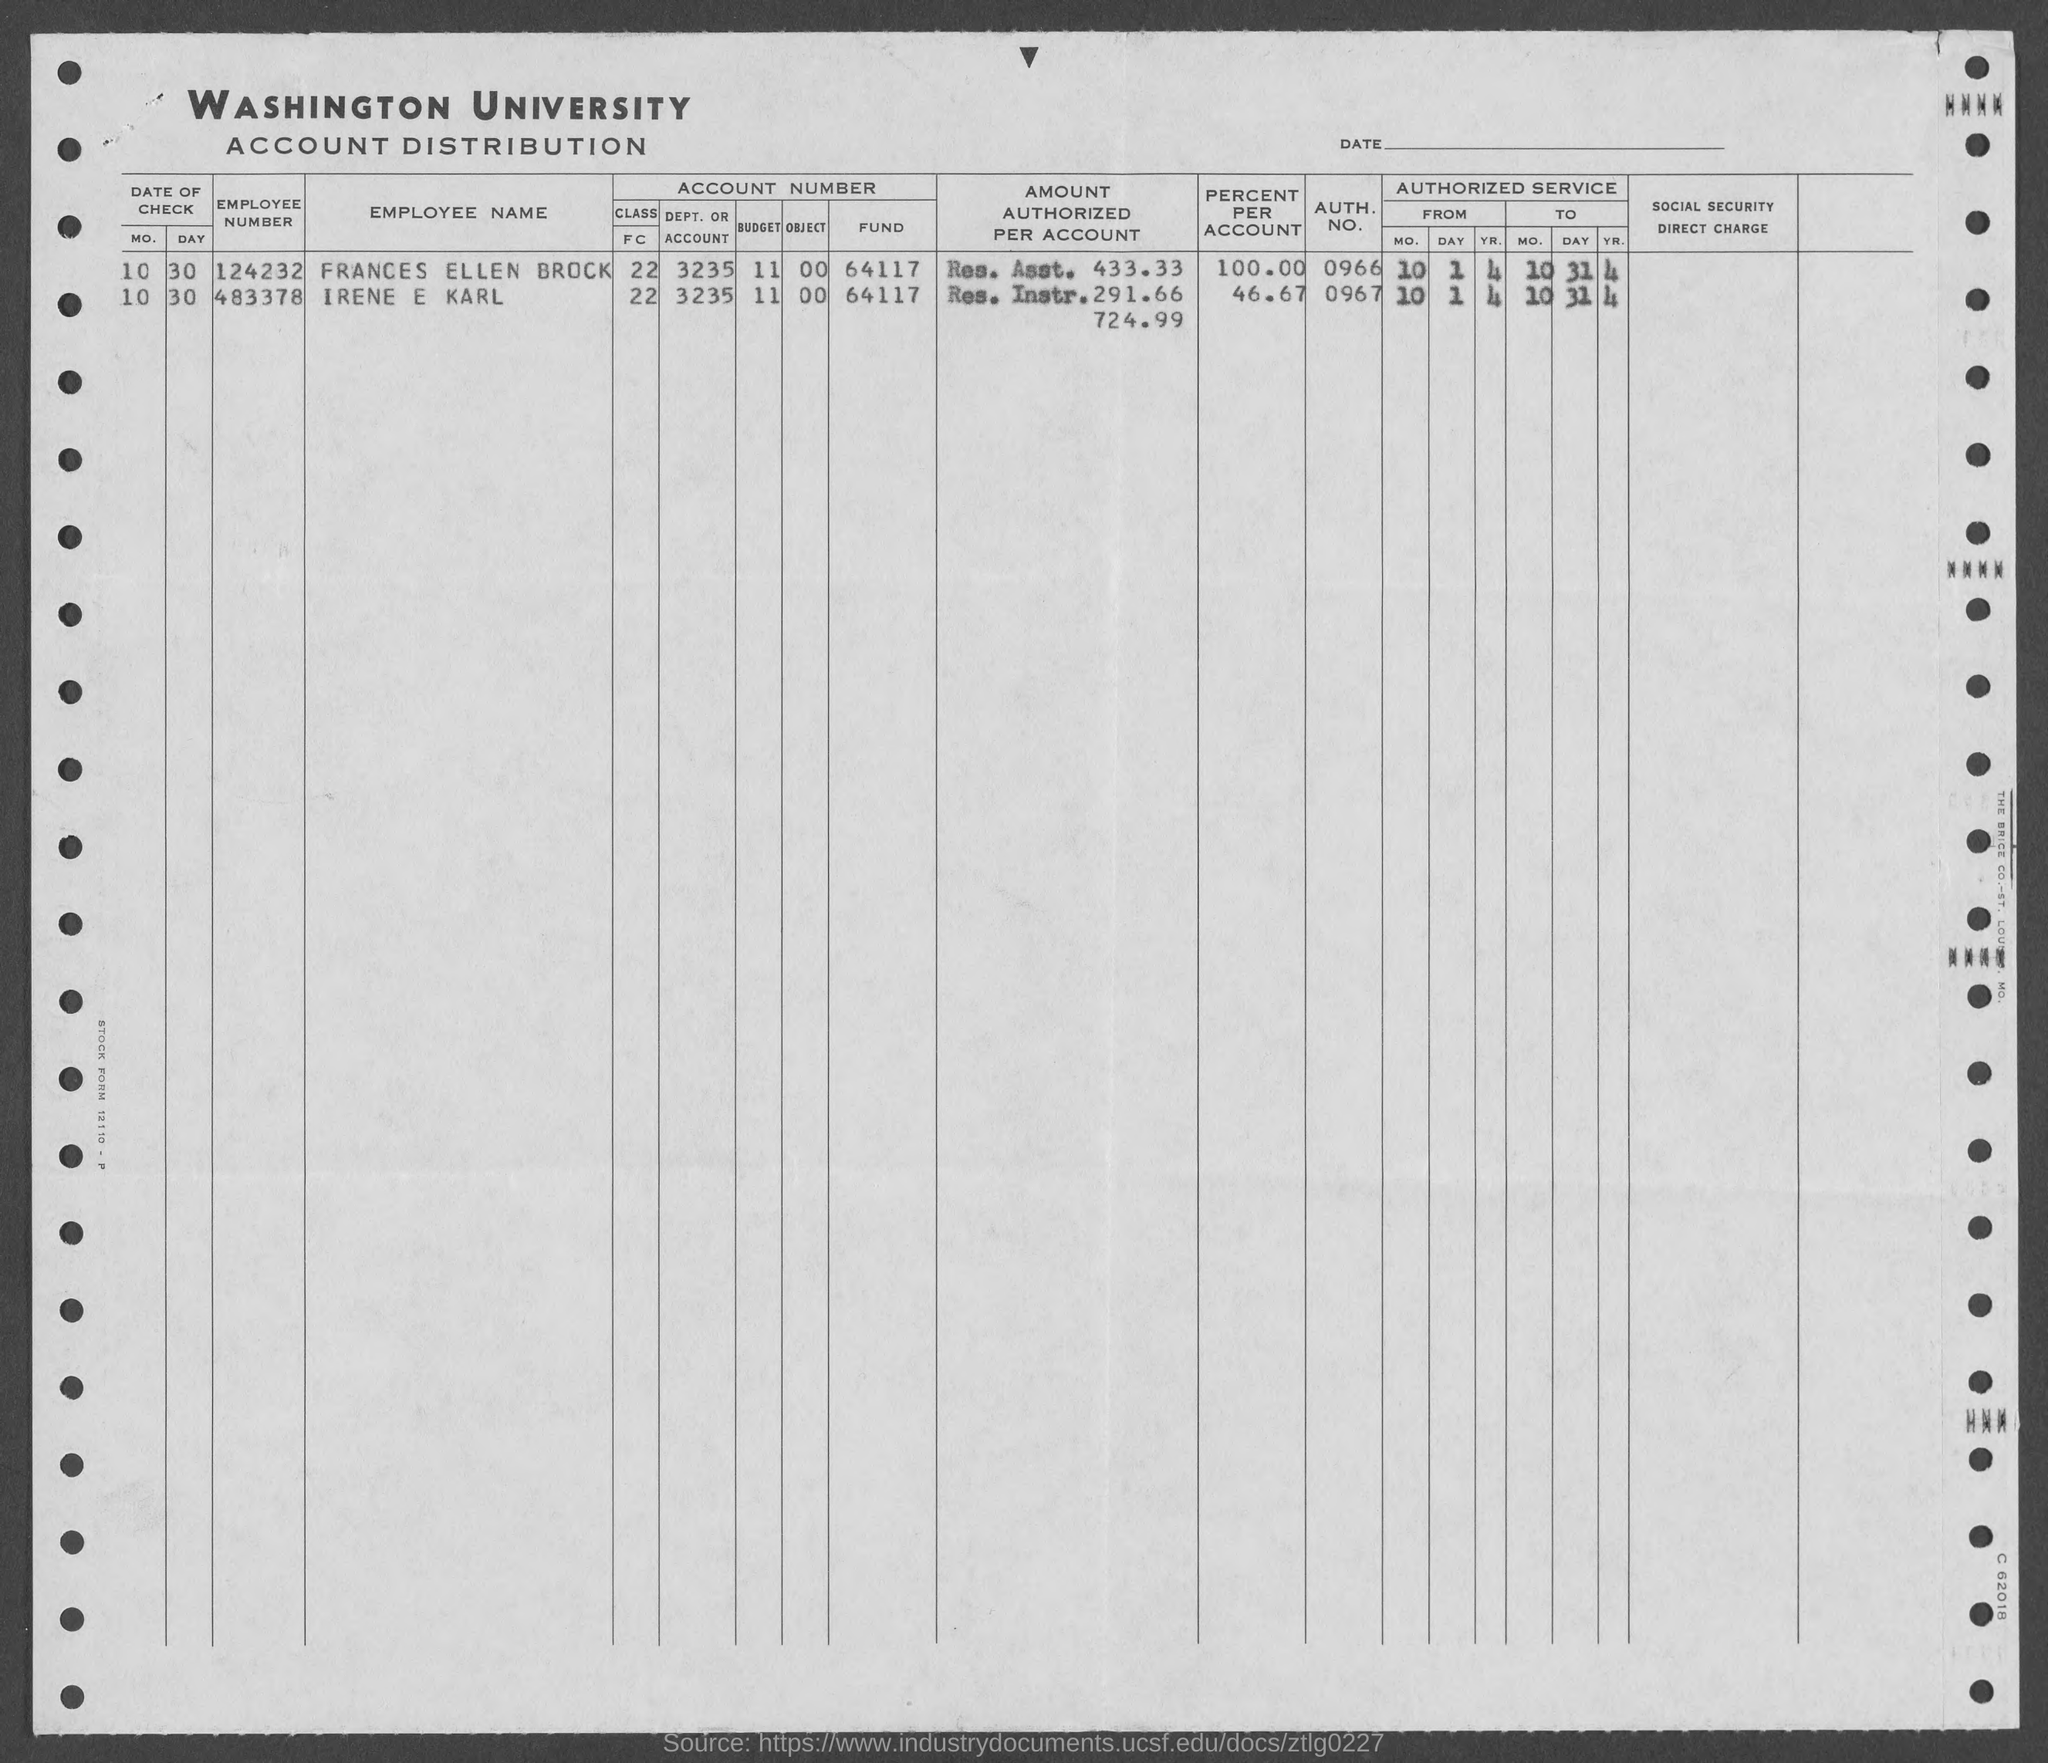Can you provide more details about the document's purpose? This appears to be a financial document from Washington University, specifically an account distribution ledger that records details such as employee names, their associated department or unit, account numbers, the amount authorized per account, and percentages, as well as authorization numbers. Its purpose is to track and manage distribution of funds within the university's accounts, possibly for budgeting and auditing purposes. How do you interpret the percentages listed under 'PERCENT AUTHORIZED ACCOUNT'? The percentages listed under 'PERCENT AUTHORIZED ACCOUNT' represent the proportion or share of the total amount that is authorized for a particular account. For example, a percentage of 100.00 implies that the account is authorized to utilize the full amount listed under 'AMOUNT AUTHORIZED PER ACCOUNT', whereas a lower percentage would indicate partial authorization relative to that fund. 